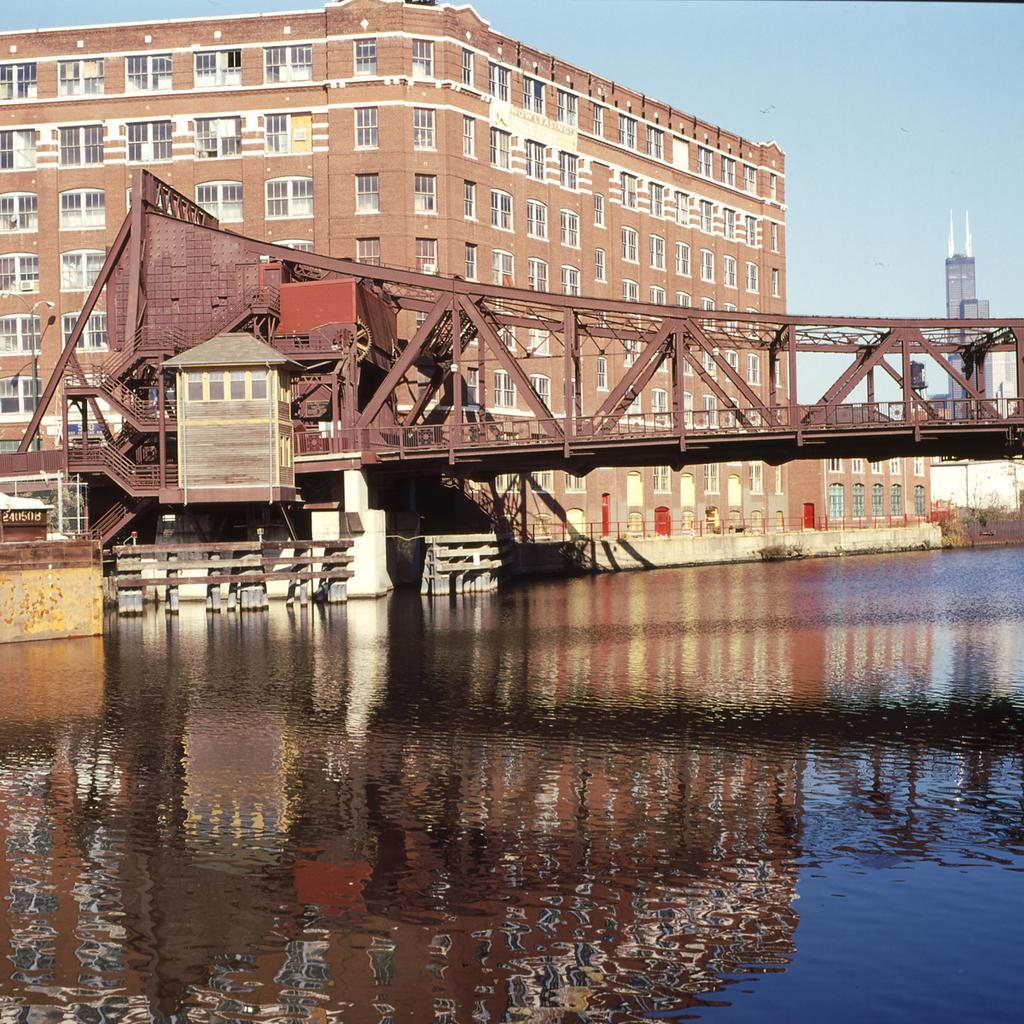What is the primary element visible in the image? There is water in the image. What structures can be seen in the background of the image? There is a bridge, a building with glass windows, and towers in the background. What is visible in the sky in the image? The sky is visible in the background of the image. What type of wood is the carpenter using to build the north side of the bridge in the image? There is no carpenter or woodworking activity present in the image. 